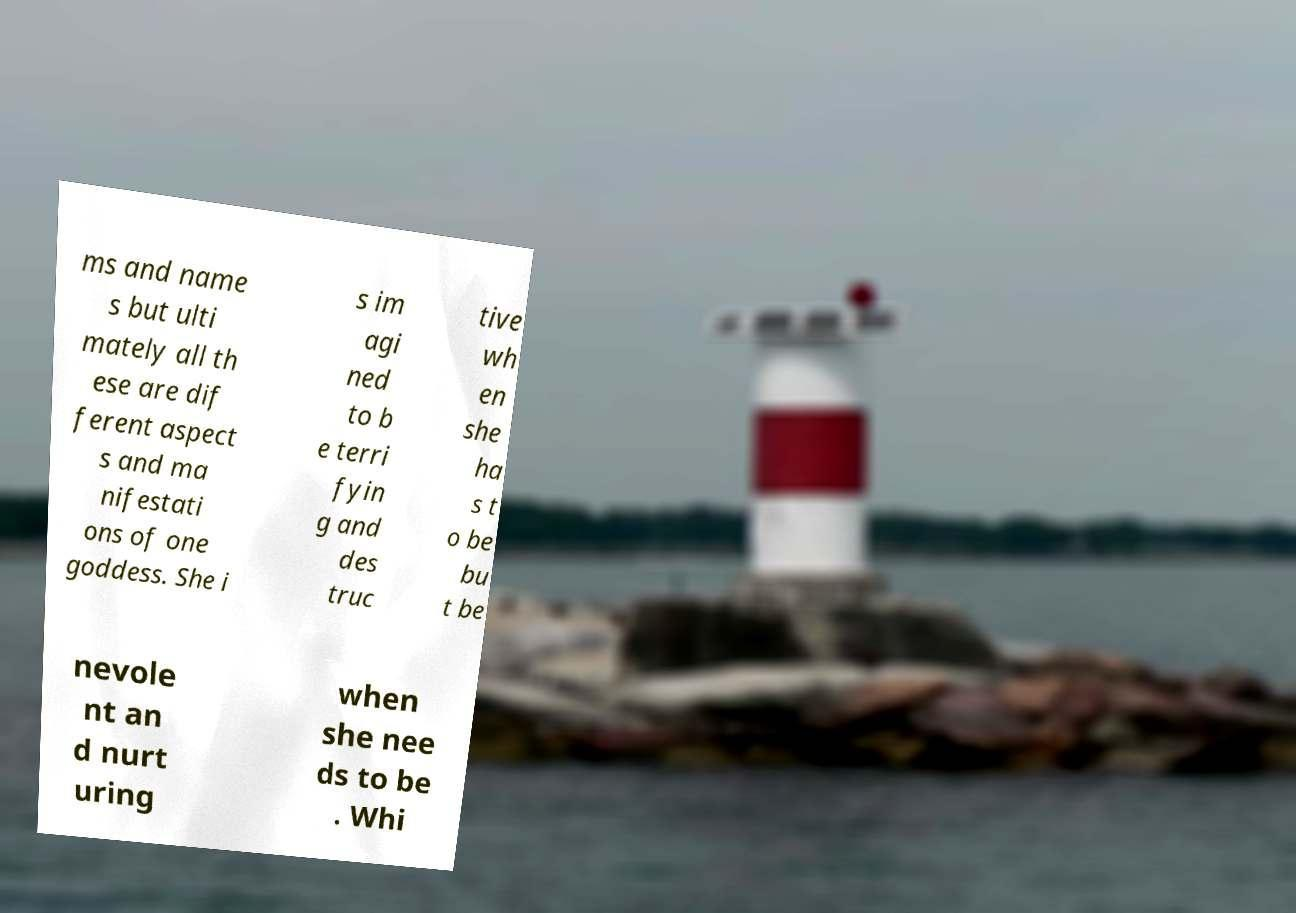Please read and relay the text visible in this image. What does it say? ms and name s but ulti mately all th ese are dif ferent aspect s and ma nifestati ons of one goddess. She i s im agi ned to b e terri fyin g and des truc tive wh en she ha s t o be bu t be nevole nt an d nurt uring when she nee ds to be . Whi 